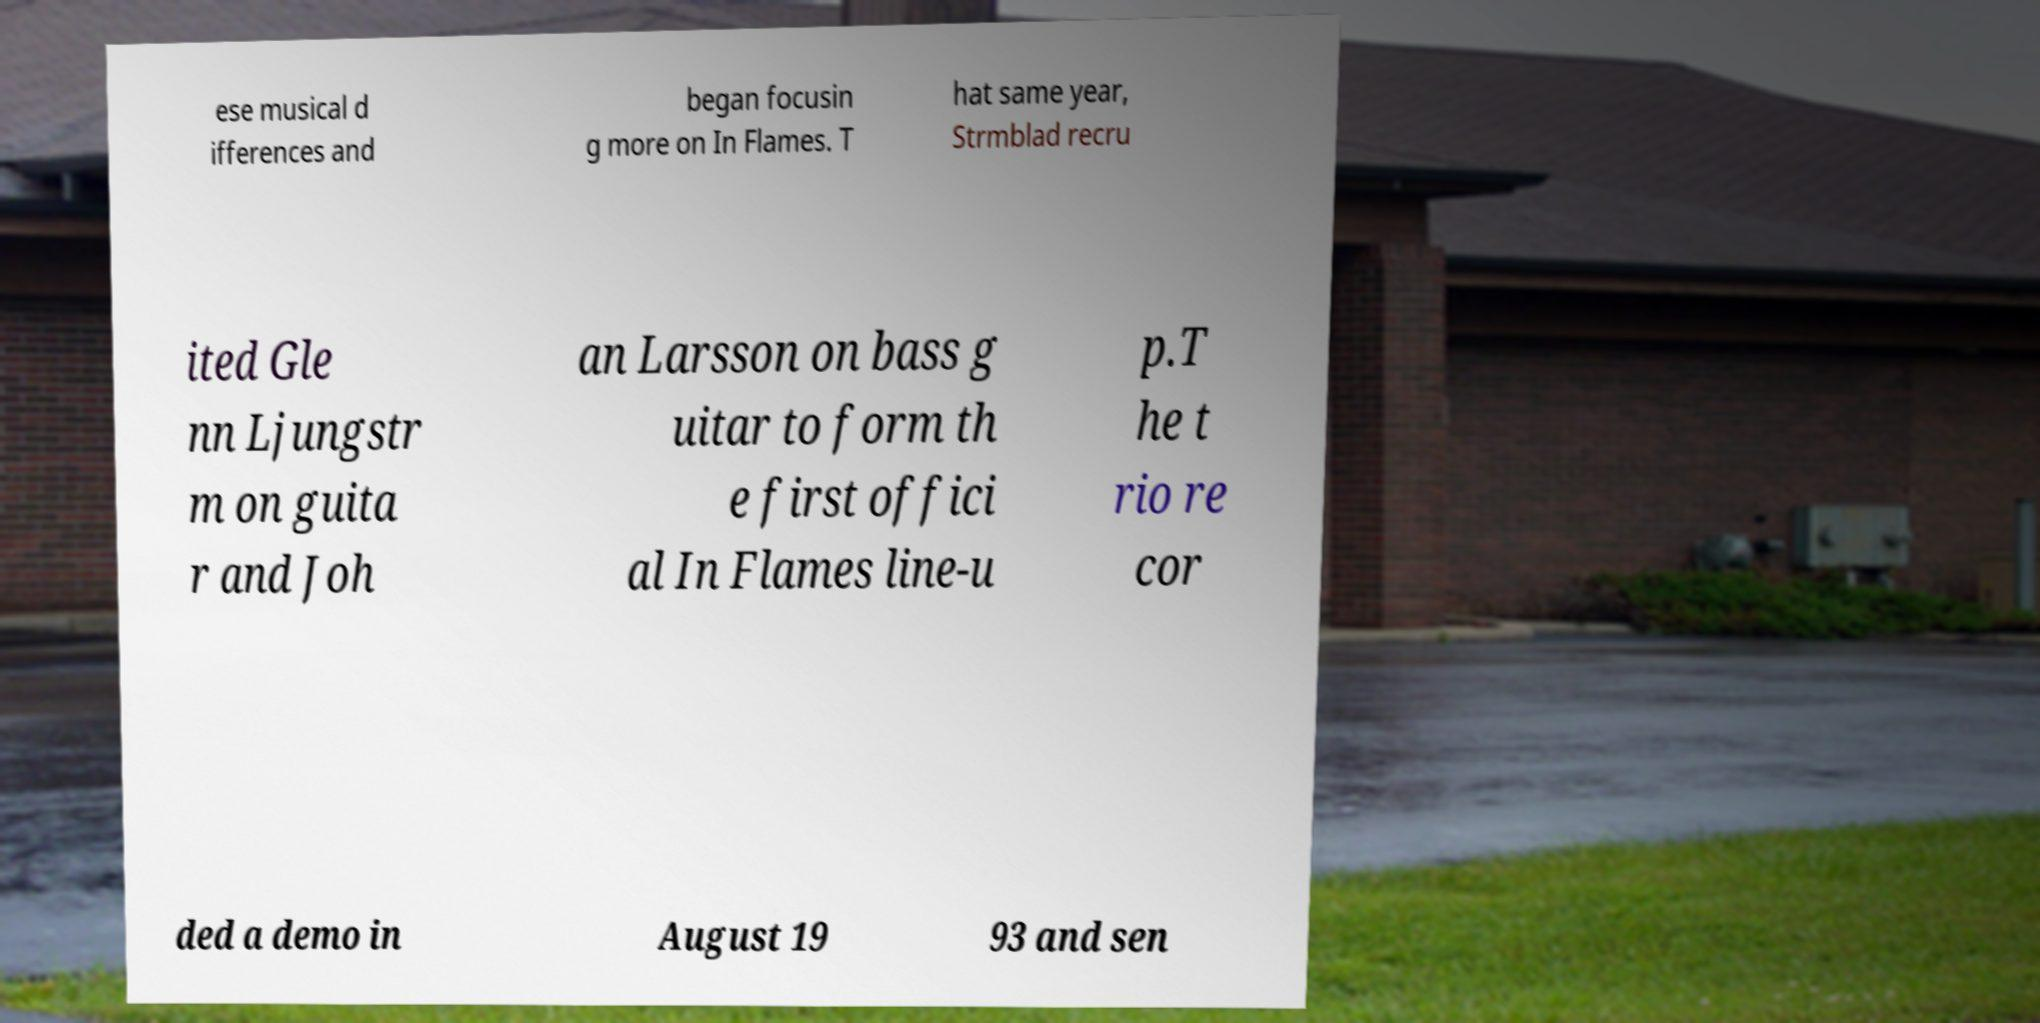Can you read and provide the text displayed in the image?This photo seems to have some interesting text. Can you extract and type it out for me? ese musical d ifferences and began focusin g more on In Flames. T hat same year, Strmblad recru ited Gle nn Ljungstr m on guita r and Joh an Larsson on bass g uitar to form th e first offici al In Flames line-u p.T he t rio re cor ded a demo in August 19 93 and sen 